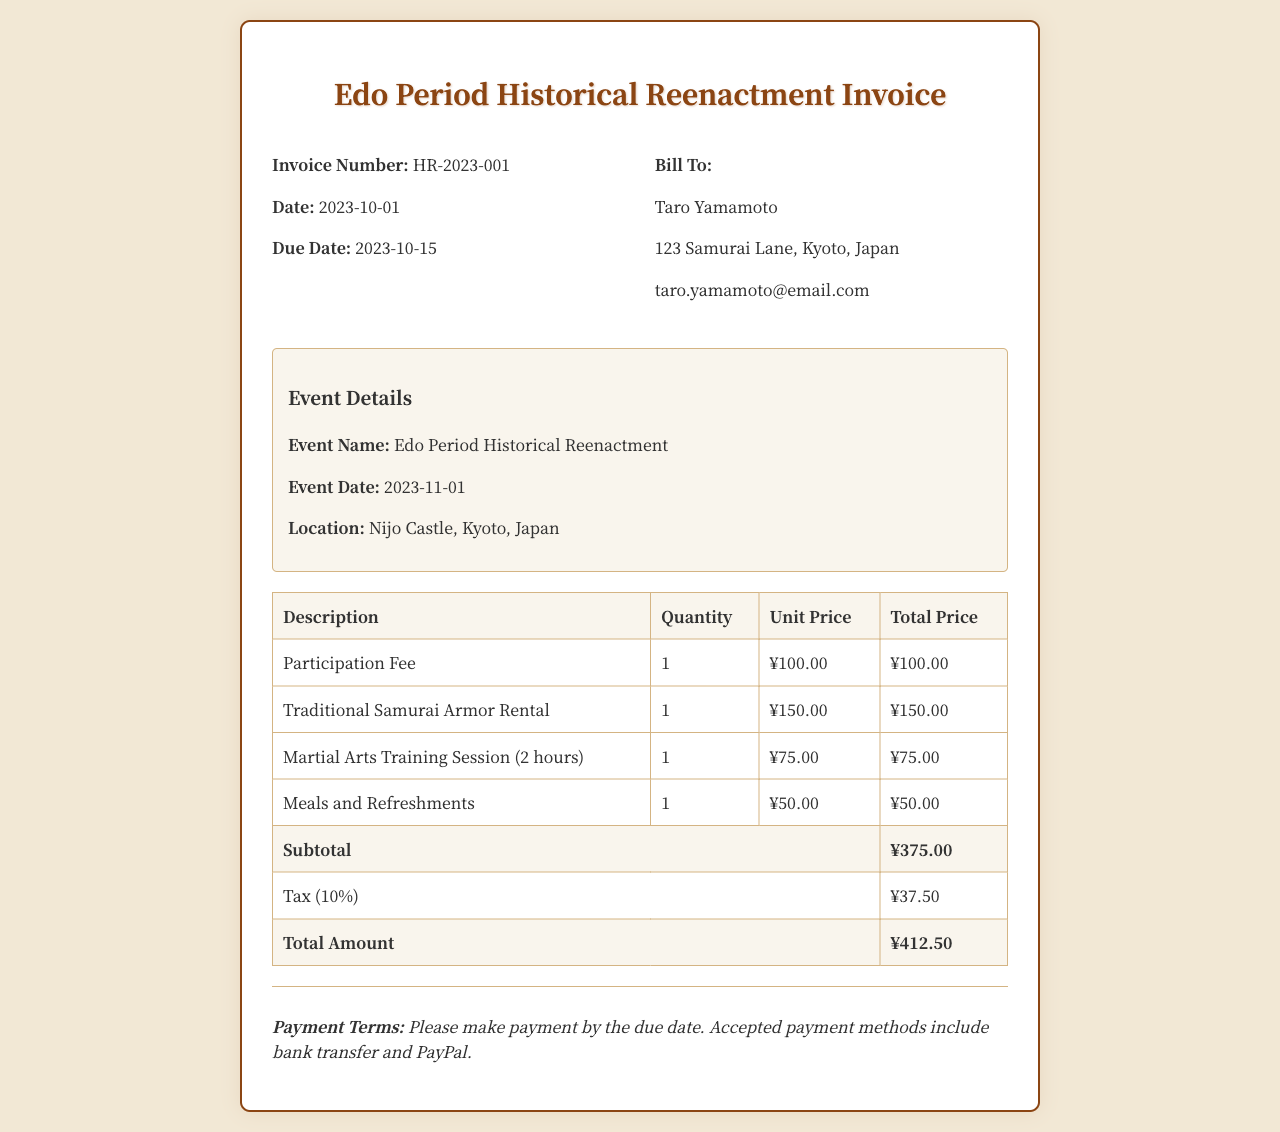What is the invoice number? The invoice number is provided in the invoice details section as a unique identifier for the invoice.
Answer: HR-2023-001 What is the due date for payment? The due date is specified in the invoice details and indicates when the payment should be made to avoid penalties.
Answer: 2023-10-15 Who is the bill to? The "Bill To" section includes the name of the person responsible for the payment of the invoice.
Answer: Taro Yamamoto What is the location of the event? The location is highlighted in the event details section and indicates where the historical reenactment will take place.
Answer: Nijo Castle, Kyoto, Japan What is the total amount due? The total amount is calculated from the subtotal and tax and represents the final payment required for the event.
Answer: ¥412.50 How much is the participation fee? The participation fee is listed in the invoice table under the description of services provided for the event.
Answer: ¥100.00 What is the tax rate applied? The tax rate is indicated in the document and is necessary for calculating the tax amount on the subtotal.
Answer: 10% What is included in the subtotal? The subtotal is the sum of all the individual line items before tax is applied, giving an overview of the costs.
Answer: ¥375.00 What forms of payment are accepted? The payment terms section states the methods that can be used to settle the invoice amount.
Answer: Bank transfer and PayPal 